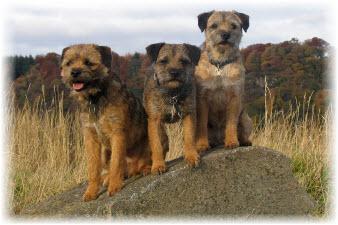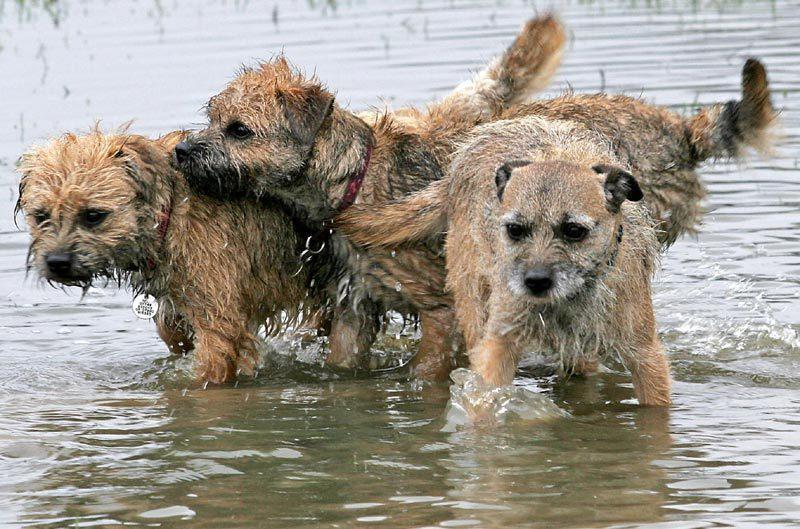The first image is the image on the left, the second image is the image on the right. Evaluate the accuracy of this statement regarding the images: "There are two dogs". Is it true? Answer yes or no. No. The first image is the image on the left, the second image is the image on the right. Analyze the images presented: Is the assertion "Exactly two small dogs are shown in an outdoor field setting." valid? Answer yes or no. No. 